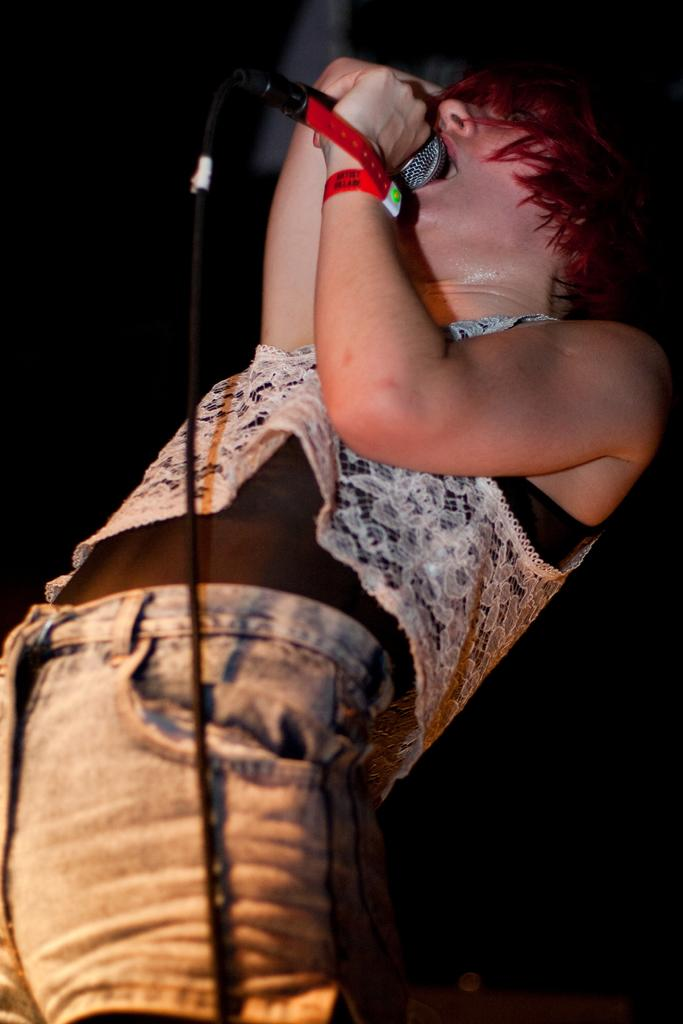What is the person in the image doing? The person is standing in the image and holding a mic in their hand. What can be seen on the person's hand? The person is wearing a red color band on their hand. How would you describe the background of the image? The background of the image is completely dark. What type of cherry is being used as a prop in the image? There is no cherry present in the image. How does the loaf of bread fit into the scene in the image? There is no loaf of bread present in the image. 